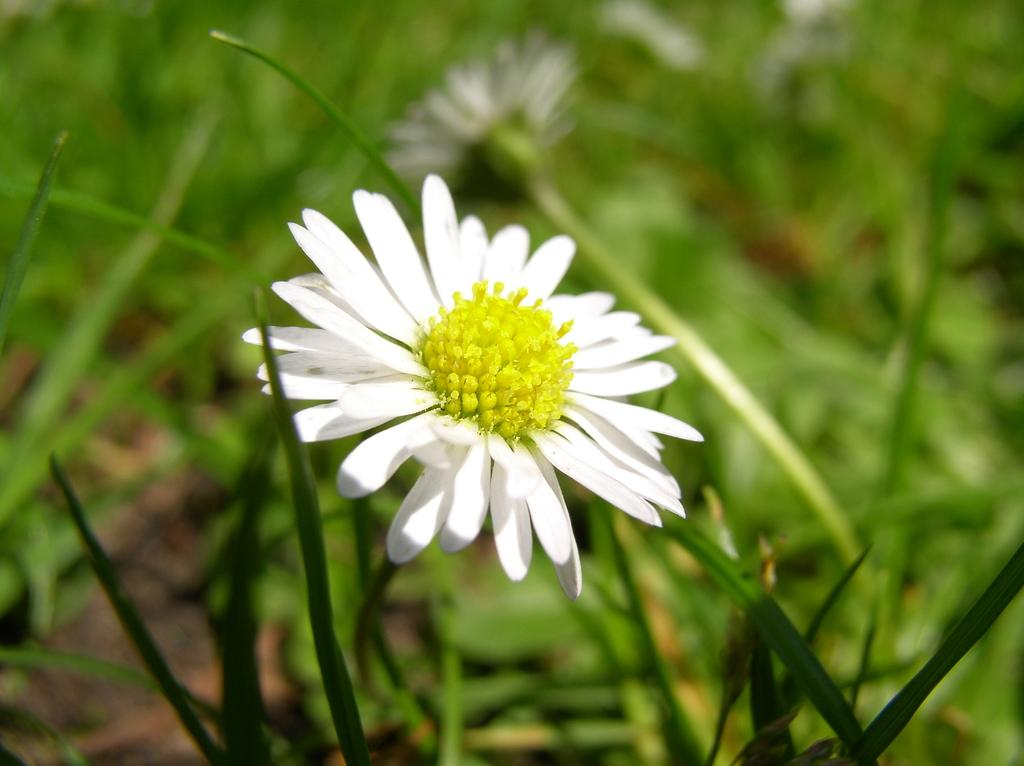What type of living organisms can be seen in the image? There are flowers in the image. What colors are the flowers and plants in the image? The flowers are in white and green color, and the plants are in green color. What type of crate is visible in the image? There is no crate present in the image. What kind of lunch is being prepared in the image? There is no lunch preparation or any food items visible in the image. 